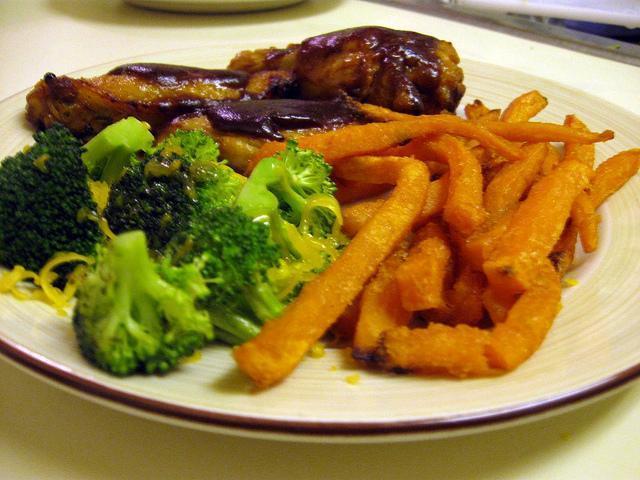How many vegetables are on the plate?
Give a very brief answer. 2. How many carrots are in the photo?
Give a very brief answer. 3. 